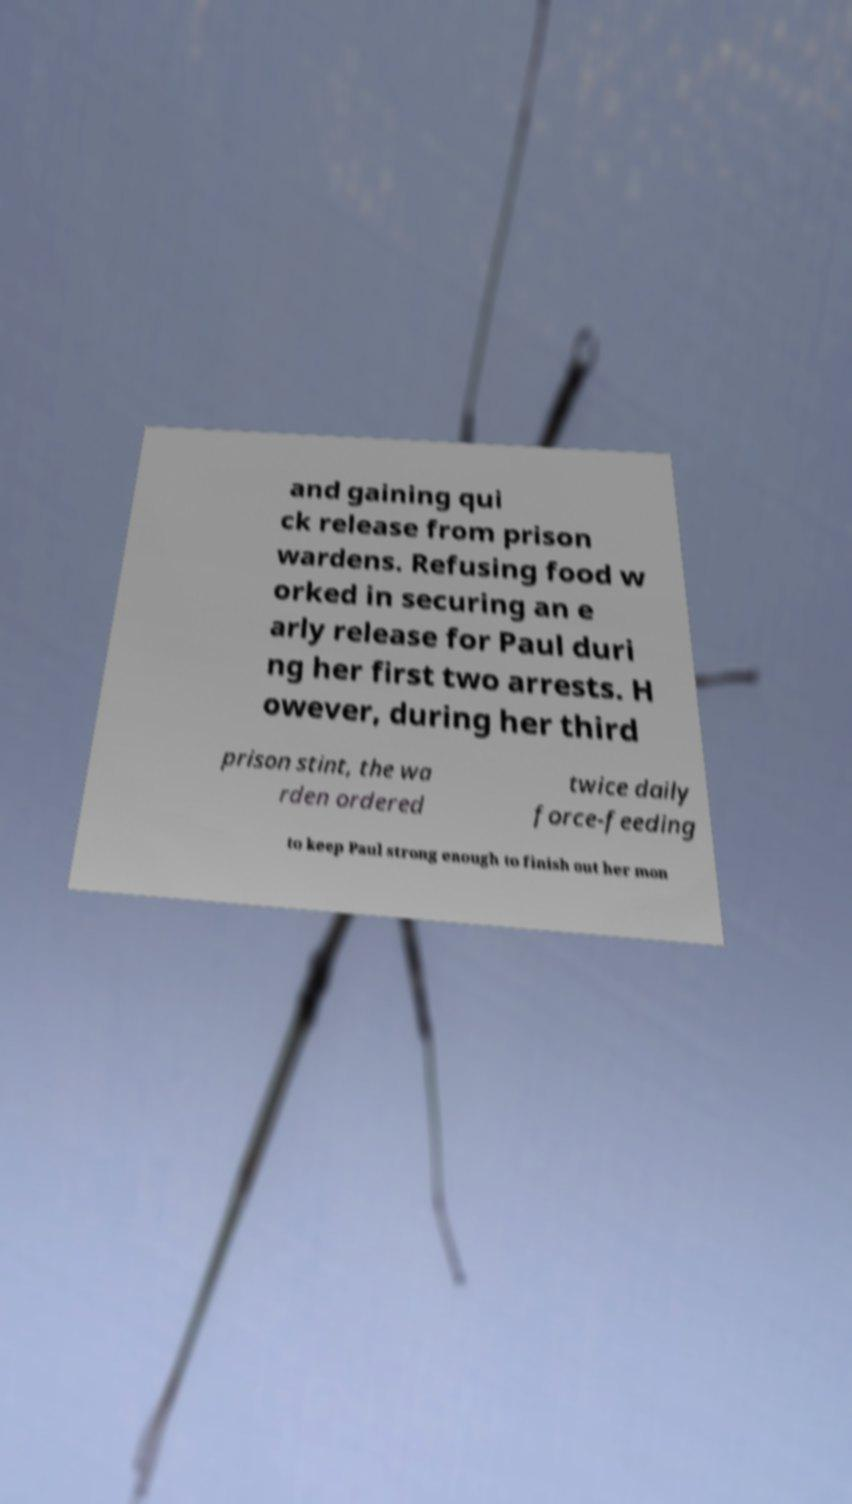Could you assist in decoding the text presented in this image and type it out clearly? and gaining qui ck release from prison wardens. Refusing food w orked in securing an e arly release for Paul duri ng her first two arrests. H owever, during her third prison stint, the wa rden ordered twice daily force-feeding to keep Paul strong enough to finish out her mon 